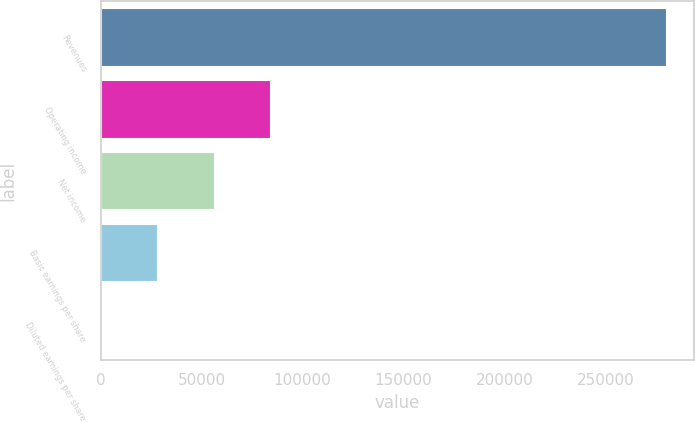Convert chart. <chart><loc_0><loc_0><loc_500><loc_500><bar_chart><fcel>Revenues<fcel>Operating income<fcel>Net income<fcel>Basic earnings per share<fcel>Diluted earnings per share<nl><fcel>280100<fcel>84030.3<fcel>56020.3<fcel>28010.4<fcel>0.4<nl></chart> 